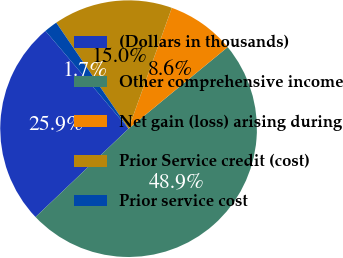<chart> <loc_0><loc_0><loc_500><loc_500><pie_chart><fcel>(Dollars in thousands)<fcel>Other comprehensive income<fcel>Net gain (loss) arising during<fcel>Prior Service credit (cost)<fcel>Prior service cost<nl><fcel>25.87%<fcel>48.87%<fcel>8.57%<fcel>15.0%<fcel>1.69%<nl></chart> 